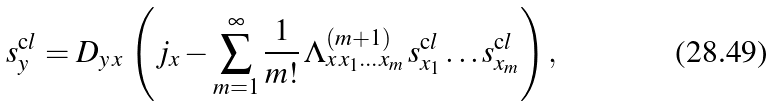Convert formula to latex. <formula><loc_0><loc_0><loc_500><loc_500>s ^ { \mathrm c l } _ { y } = D _ { y \, x } \, \left ( j _ { x } - \sum _ { m = 1 } ^ { \infty } \frac { 1 } { m ! } \, \Lambda ^ { ( m + 1 ) } _ { x \, x _ { 1 } \dots x _ { m } } \, s ^ { \mathrm c l } _ { x _ { 1 } } \dots s ^ { \mathrm c l } _ { x _ { m } } \right ) ,</formula> 